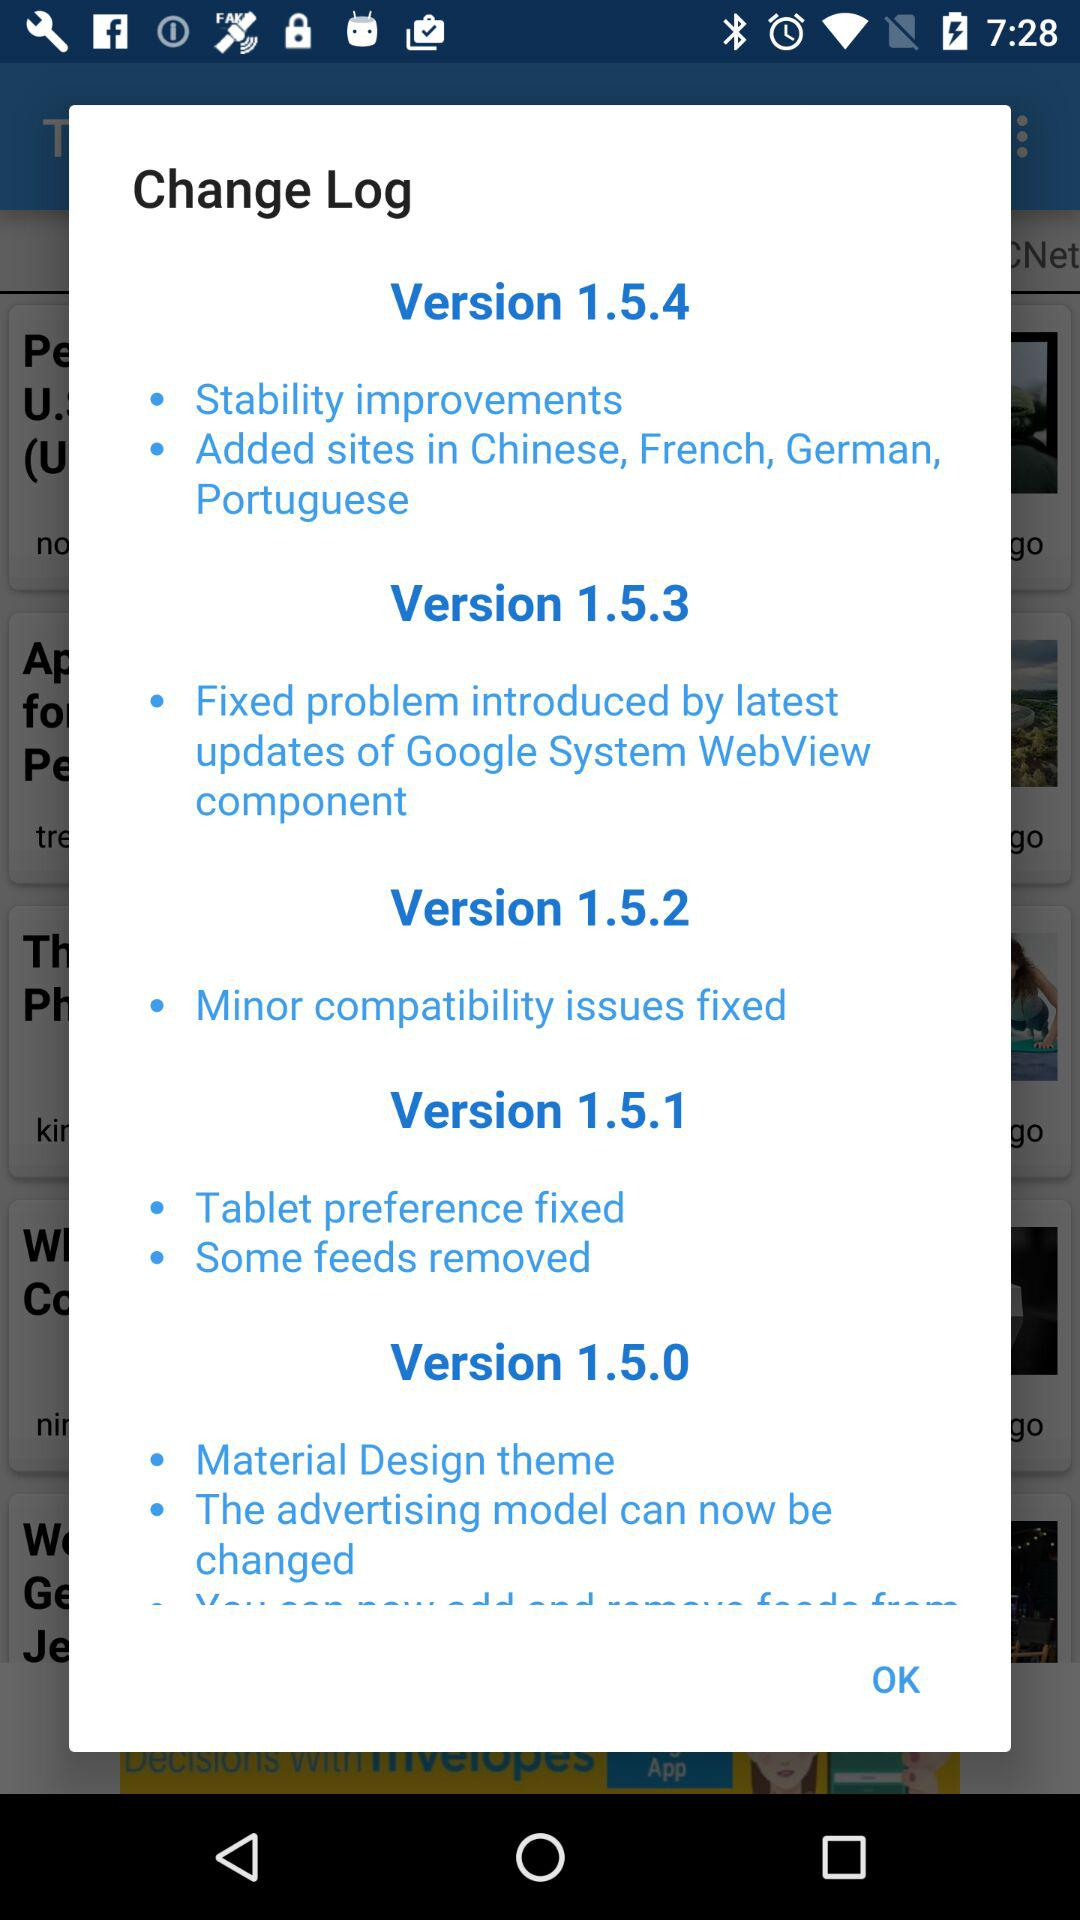What is the version? The versions are 1.5.4, 1.5.3, 1.5.2, 1.5.1 and 1.5.0. 